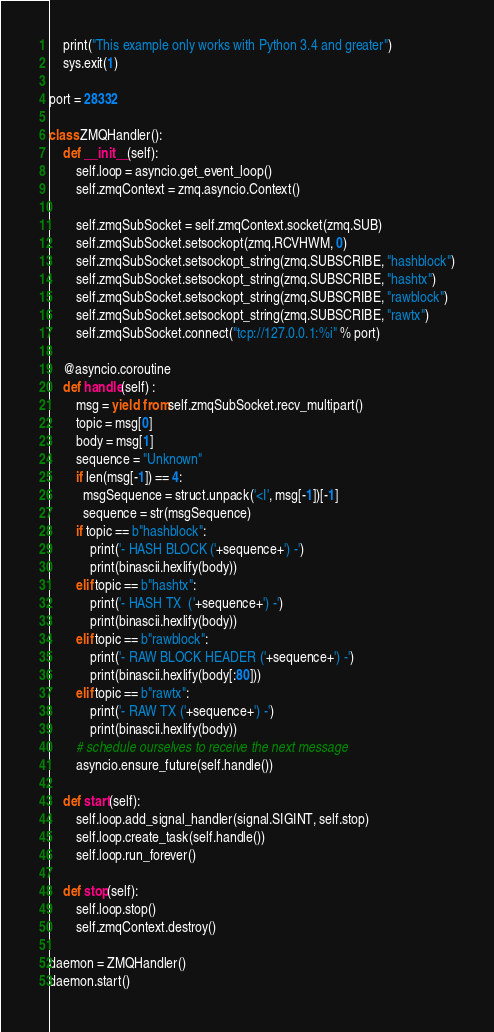<code> <loc_0><loc_0><loc_500><loc_500><_Python_>    print("This example only works with Python 3.4 and greater")
    sys.exit(1)

port = 28332

class ZMQHandler():
    def __init__(self):
        self.loop = asyncio.get_event_loop()
        self.zmqContext = zmq.asyncio.Context()

        self.zmqSubSocket = self.zmqContext.socket(zmq.SUB)
        self.zmqSubSocket.setsockopt(zmq.RCVHWM, 0)
        self.zmqSubSocket.setsockopt_string(zmq.SUBSCRIBE, "hashblock")
        self.zmqSubSocket.setsockopt_string(zmq.SUBSCRIBE, "hashtx")
        self.zmqSubSocket.setsockopt_string(zmq.SUBSCRIBE, "rawblock")
        self.zmqSubSocket.setsockopt_string(zmq.SUBSCRIBE, "rawtx")
        self.zmqSubSocket.connect("tcp://127.0.0.1:%i" % port)

    @asyncio.coroutine
    def handle(self) :
        msg = yield from self.zmqSubSocket.recv_multipart()
        topic = msg[0]
        body = msg[1]
        sequence = "Unknown"
        if len(msg[-1]) == 4:
          msgSequence = struct.unpack('<I', msg[-1])[-1]
          sequence = str(msgSequence)
        if topic == b"hashblock":
            print('- HASH BLOCK ('+sequence+') -')
            print(binascii.hexlify(body))
        elif topic == b"hashtx":
            print('- HASH TX  ('+sequence+') -')
            print(binascii.hexlify(body))
        elif topic == b"rawblock":
            print('- RAW BLOCK HEADER ('+sequence+') -')
            print(binascii.hexlify(body[:80]))
        elif topic == b"rawtx":
            print('- RAW TX ('+sequence+') -')
            print(binascii.hexlify(body))
        # schedule ourselves to receive the next message
        asyncio.ensure_future(self.handle())

    def start(self):
        self.loop.add_signal_handler(signal.SIGINT, self.stop)
        self.loop.create_task(self.handle())
        self.loop.run_forever()

    def stop(self):
        self.loop.stop()
        self.zmqContext.destroy()

daemon = ZMQHandler()
daemon.start()
</code> 